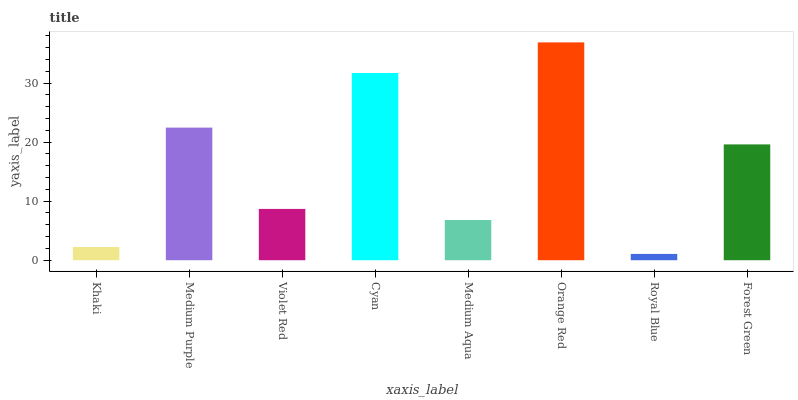Is Royal Blue the minimum?
Answer yes or no. Yes. Is Orange Red the maximum?
Answer yes or no. Yes. Is Medium Purple the minimum?
Answer yes or no. No. Is Medium Purple the maximum?
Answer yes or no. No. Is Medium Purple greater than Khaki?
Answer yes or no. Yes. Is Khaki less than Medium Purple?
Answer yes or no. Yes. Is Khaki greater than Medium Purple?
Answer yes or no. No. Is Medium Purple less than Khaki?
Answer yes or no. No. Is Forest Green the high median?
Answer yes or no. Yes. Is Violet Red the low median?
Answer yes or no. Yes. Is Medium Aqua the high median?
Answer yes or no. No. Is Medium Aqua the low median?
Answer yes or no. No. 